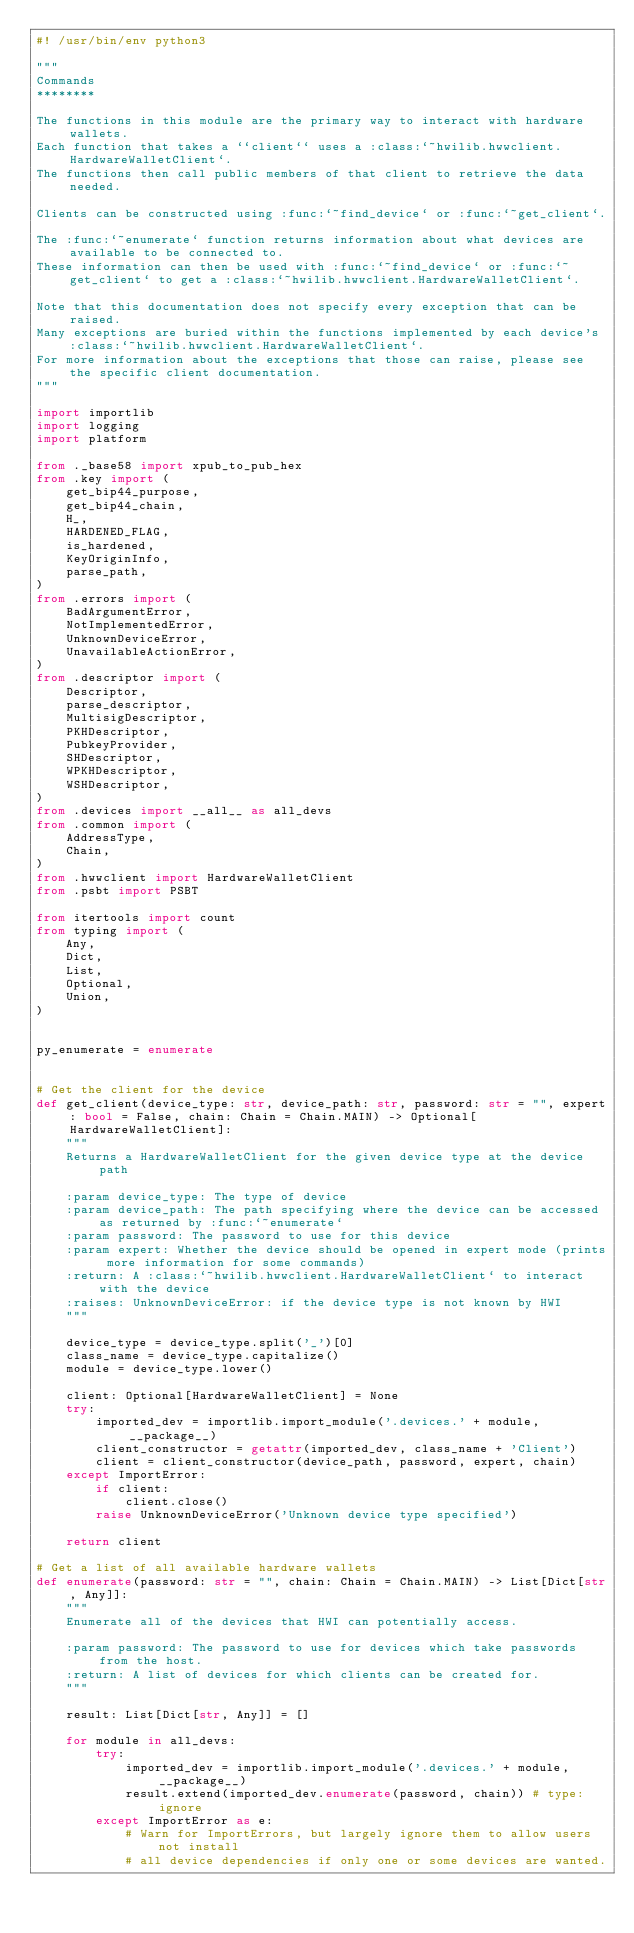<code> <loc_0><loc_0><loc_500><loc_500><_Python_>#! /usr/bin/env python3

"""
Commands
********

The functions in this module are the primary way to interact with hardware wallets.
Each function that takes a ``client`` uses a :class:`~hwilib.hwwclient.HardwareWalletClient`.
The functions then call public members of that client to retrieve the data needed.

Clients can be constructed using :func:`~find_device` or :func:`~get_client`.

The :func:`~enumerate` function returns information about what devices are available to be connected to.
These information can then be used with :func:`~find_device` or :func:`~get_client` to get a :class:`~hwilib.hwwclient.HardwareWalletClient`.

Note that this documentation does not specify every exception that can be raised.
Many exceptions are buried within the functions implemented by each device's :class:`~hwilib.hwwclient.HardwareWalletClient`.
For more information about the exceptions that those can raise, please see the specific client documentation.
"""

import importlib
import logging
import platform

from ._base58 import xpub_to_pub_hex
from .key import (
    get_bip44_purpose,
    get_bip44_chain,
    H_,
    HARDENED_FLAG,
    is_hardened,
    KeyOriginInfo,
    parse_path,
)
from .errors import (
    BadArgumentError,
    NotImplementedError,
    UnknownDeviceError,
    UnavailableActionError,
)
from .descriptor import (
    Descriptor,
    parse_descriptor,
    MultisigDescriptor,
    PKHDescriptor,
    PubkeyProvider,
    SHDescriptor,
    WPKHDescriptor,
    WSHDescriptor,
)
from .devices import __all__ as all_devs
from .common import (
    AddressType,
    Chain,
)
from .hwwclient import HardwareWalletClient
from .psbt import PSBT

from itertools import count
from typing import (
    Any,
    Dict,
    List,
    Optional,
    Union,
)


py_enumerate = enumerate


# Get the client for the device
def get_client(device_type: str, device_path: str, password: str = "", expert: bool = False, chain: Chain = Chain.MAIN) -> Optional[HardwareWalletClient]:
    """
    Returns a HardwareWalletClient for the given device type at the device path

    :param device_type: The type of device
    :param device_path: The path specifying where the device can be accessed as returned by :func:`~enumerate`
    :param password: The password to use for this device
    :param expert: Whether the device should be opened in expert mode (prints more information for some commands)
    :return: A :class:`~hwilib.hwwclient.HardwareWalletClient` to interact with the device
    :raises: UnknownDeviceError: if the device type is not known by HWI
    """

    device_type = device_type.split('_')[0]
    class_name = device_type.capitalize()
    module = device_type.lower()

    client: Optional[HardwareWalletClient] = None
    try:
        imported_dev = importlib.import_module('.devices.' + module, __package__)
        client_constructor = getattr(imported_dev, class_name + 'Client')
        client = client_constructor(device_path, password, expert, chain)
    except ImportError:
        if client:
            client.close()
        raise UnknownDeviceError('Unknown device type specified')

    return client

# Get a list of all available hardware wallets
def enumerate(password: str = "", chain: Chain = Chain.MAIN) -> List[Dict[str, Any]]:
    """
    Enumerate all of the devices that HWI can potentially access.

    :param password: The password to use for devices which take passwords from the host.
    :return: A list of devices for which clients can be created for.
    """

    result: List[Dict[str, Any]] = []

    for module in all_devs:
        try:
            imported_dev = importlib.import_module('.devices.' + module, __package__)
            result.extend(imported_dev.enumerate(password, chain)) # type: ignore
        except ImportError as e:
            # Warn for ImportErrors, but largely ignore them to allow users not install
            # all device dependencies if only one or some devices are wanted.</code> 